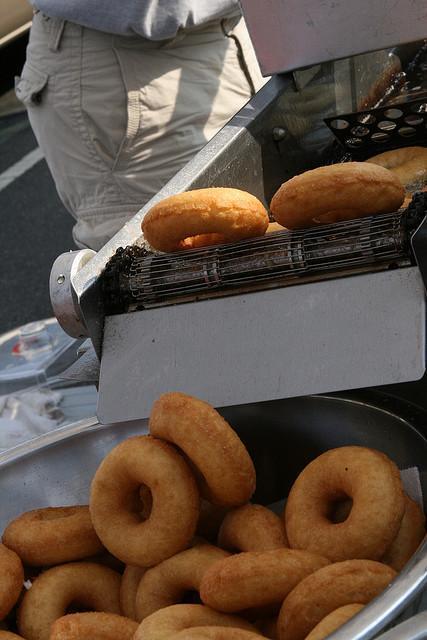How many donuts are visible?
Give a very brief answer. 10. 